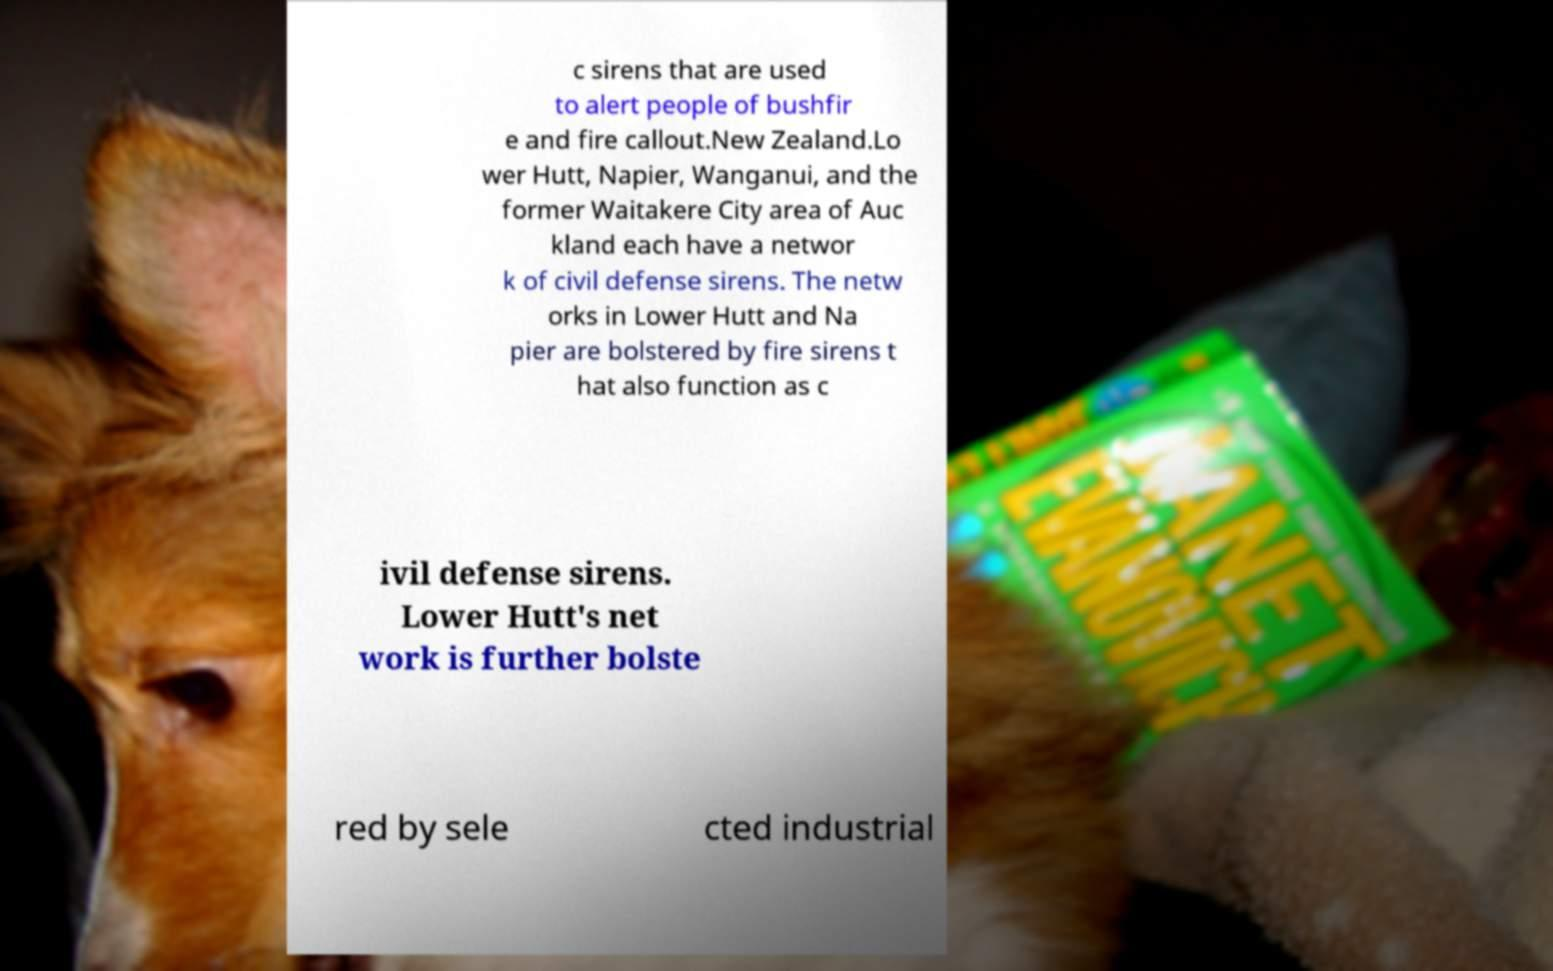Can you accurately transcribe the text from the provided image for me? c sirens that are used to alert people of bushfir e and fire callout.New Zealand.Lo wer Hutt, Napier, Wanganui, and the former Waitakere City area of Auc kland each have a networ k of civil defense sirens. The netw orks in Lower Hutt and Na pier are bolstered by fire sirens t hat also function as c ivil defense sirens. Lower Hutt's net work is further bolste red by sele cted industrial 